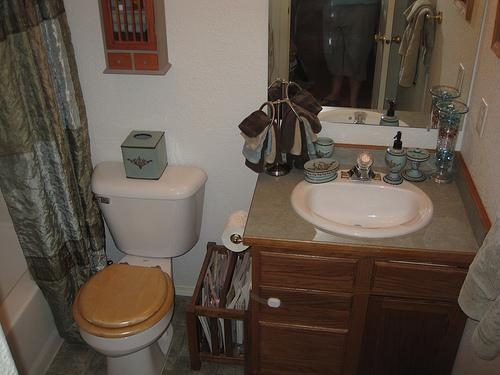Describe the position of the water tank relative to the toilet. The white water tank is positioned on the top of the toilet, slightly towards the left side as seen from the front. Provide a detailed description of the scene in the image. The image depicts a bathroom containing a white toilet with a brown wooden seat, a wooden magazine rack with numerous magazines, a wooden cabinet under a white sink, a large mirror, a towel holder with handclothes, a small bag on the sink, and a dark shower curtain. There are also several other items such as a tissue box, a toilet paper roll, and an electric outlet on the wall. What is presented on the counter and what is it for? There is a towel holder on the counter, mainly for holding handclothes, which are utilized for drying hands after washing them. What is the function of the electrical plug in the image? The electrical plug on the wall serves as an outlet for various devices, such as hairdryers and electric toothbrushes, in the bathroom. What's the sentiment this bathroom evokes? The bathroom evokes a calm, organized, and homey sentiment, with the wooden elements, magazines to read, and items placed neatly. What type of items are hanged in the rack and what is their purpose? Socks are hanged in the rack, possibly to let them dry after being washed or used. Count the number of objects that are wooden in this image. There are six wooden objects: the toilet seat, the drawer, the cabinet under the sink, the toilet seat lid, the magazine rack next to the toilet, and the cover. Identify two objects that have interactions with the sink. Hand soap and a small bag are placed on the sink, with the hand soap being used for washing hands, and the small bag possibly holding toiletries. How many objects are mentioned in this image and what are their colors? There are 16 objects mentioned with specific colors: a brown toilet seat, a white sink, a white water tank, a brown and grey curtain, a large glass object, a white tissue roll, a brown cover, a white toilet roll, brown wooden drawers and cabinet, a white bathroom toilet, a brown wooden toilet seat lid, an oval-shaped white sink, a white toilet with a brown lid, a white toilet with a brown seat, a green tissue box on the white tank, and a white electric outlet on the wall. What kind of complex reasoning can be gathered from the objects in this bathroom? The presence of wooden elements, a full magazine rack, and a towel holder with handclothes indicate that the residents value relaxation, comfort and likely to have an eco-friendly or nature-inspired lifestyle. Is the blue toothbrush on the counter next to the sink? Make sure to put it away after using it. No, it's not mentioned in the image. Are the decorative candles on the shelf already lit? Blow them out before leaving the bathroom. There is no mention of decorative candles or a shelf in the image information, so mentioning them in an instruction would be misleading and incorrect. Can you see the small plant near the window? Water the plant every day to keep it healthy. There's no mention of any plant or window in the provided image information. Referring to a plant or window in the instruction will be misleading. 